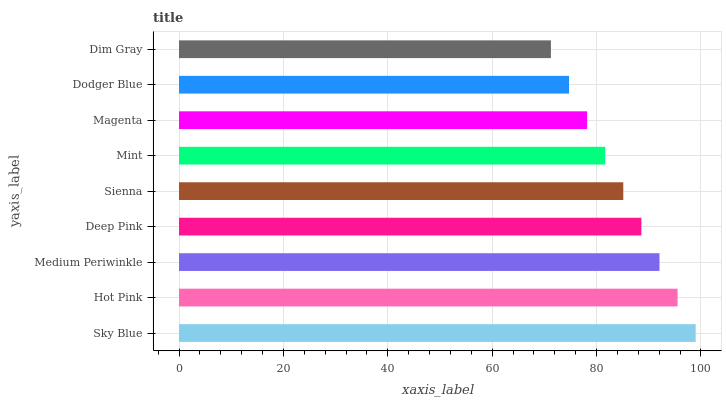Is Dim Gray the minimum?
Answer yes or no. Yes. Is Sky Blue the maximum?
Answer yes or no. Yes. Is Hot Pink the minimum?
Answer yes or no. No. Is Hot Pink the maximum?
Answer yes or no. No. Is Sky Blue greater than Hot Pink?
Answer yes or no. Yes. Is Hot Pink less than Sky Blue?
Answer yes or no. Yes. Is Hot Pink greater than Sky Blue?
Answer yes or no. No. Is Sky Blue less than Hot Pink?
Answer yes or no. No. Is Sienna the high median?
Answer yes or no. Yes. Is Sienna the low median?
Answer yes or no. Yes. Is Magenta the high median?
Answer yes or no. No. Is Sky Blue the low median?
Answer yes or no. No. 